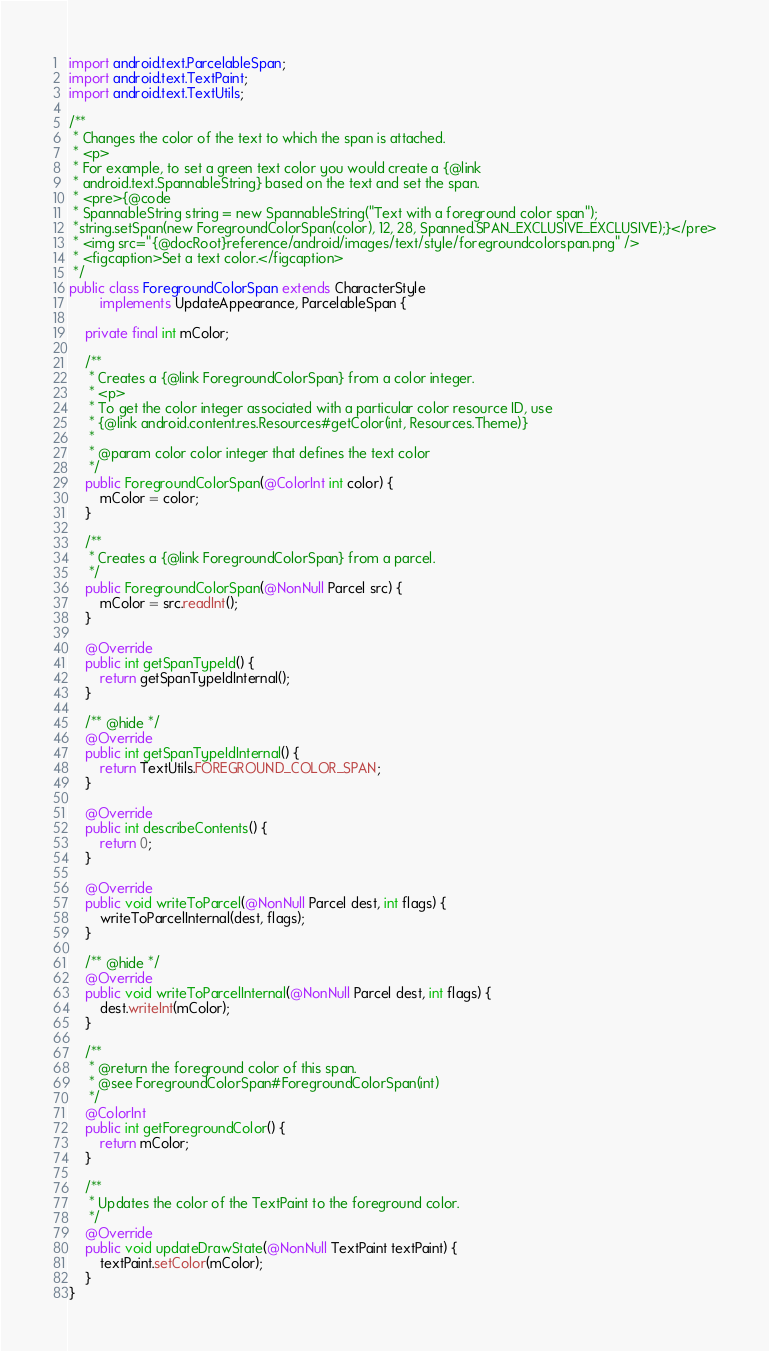<code> <loc_0><loc_0><loc_500><loc_500><_Java_>import android.text.ParcelableSpan;
import android.text.TextPaint;
import android.text.TextUtils;

/**
 * Changes the color of the text to which the span is attached.
 * <p>
 * For example, to set a green text color you would create a {@link
 * android.text.SpannableString} based on the text and set the span.
 * <pre>{@code
 * SpannableString string = new SpannableString("Text with a foreground color span");
 *string.setSpan(new ForegroundColorSpan(color), 12, 28, Spanned.SPAN_EXCLUSIVE_EXCLUSIVE);}</pre>
 * <img src="{@docRoot}reference/android/images/text/style/foregroundcolorspan.png" />
 * <figcaption>Set a text color.</figcaption>
 */
public class ForegroundColorSpan extends CharacterStyle
        implements UpdateAppearance, ParcelableSpan {

    private final int mColor;

    /**
     * Creates a {@link ForegroundColorSpan} from a color integer.
     * <p>
     * To get the color integer associated with a particular color resource ID, use
     * {@link android.content.res.Resources#getColor(int, Resources.Theme)}
     *
     * @param color color integer that defines the text color
     */
    public ForegroundColorSpan(@ColorInt int color) {
        mColor = color;
    }

    /**
     * Creates a {@link ForegroundColorSpan} from a parcel.
     */
    public ForegroundColorSpan(@NonNull Parcel src) {
        mColor = src.readInt();
    }

    @Override
    public int getSpanTypeId() {
        return getSpanTypeIdInternal();
    }

    /** @hide */
    @Override
    public int getSpanTypeIdInternal() {
        return TextUtils.FOREGROUND_COLOR_SPAN;
    }

    @Override
    public int describeContents() {
        return 0;
    }

    @Override
    public void writeToParcel(@NonNull Parcel dest, int flags) {
        writeToParcelInternal(dest, flags);
    }

    /** @hide */
    @Override
    public void writeToParcelInternal(@NonNull Parcel dest, int flags) {
        dest.writeInt(mColor);
    }

    /**
     * @return the foreground color of this span.
     * @see ForegroundColorSpan#ForegroundColorSpan(int)
     */
    @ColorInt
    public int getForegroundColor() {
        return mColor;
    }

    /**
     * Updates the color of the TextPaint to the foreground color.
     */
    @Override
    public void updateDrawState(@NonNull TextPaint textPaint) {
        textPaint.setColor(mColor);
    }
}
</code> 